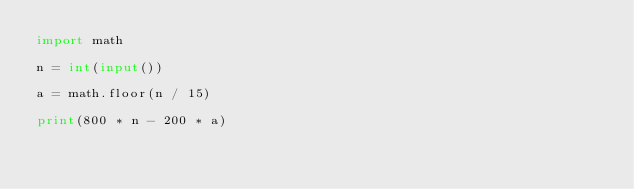<code> <loc_0><loc_0><loc_500><loc_500><_Python_>import math

n = int(input())

a = math.floor(n / 15)

print(800 * n - 200 * a)</code> 